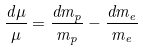Convert formula to latex. <formula><loc_0><loc_0><loc_500><loc_500>\frac { d \mu } { \mu } = \frac { d m _ { p } } { m _ { p } } - \frac { d m _ { e } } { m _ { e } }</formula> 